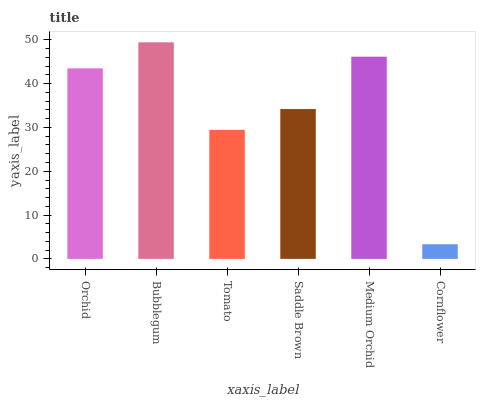Is Tomato the minimum?
Answer yes or no. No. Is Tomato the maximum?
Answer yes or no. No. Is Bubblegum greater than Tomato?
Answer yes or no. Yes. Is Tomato less than Bubblegum?
Answer yes or no. Yes. Is Tomato greater than Bubblegum?
Answer yes or no. No. Is Bubblegum less than Tomato?
Answer yes or no. No. Is Orchid the high median?
Answer yes or no. Yes. Is Saddle Brown the low median?
Answer yes or no. Yes. Is Medium Orchid the high median?
Answer yes or no. No. Is Tomato the low median?
Answer yes or no. No. 